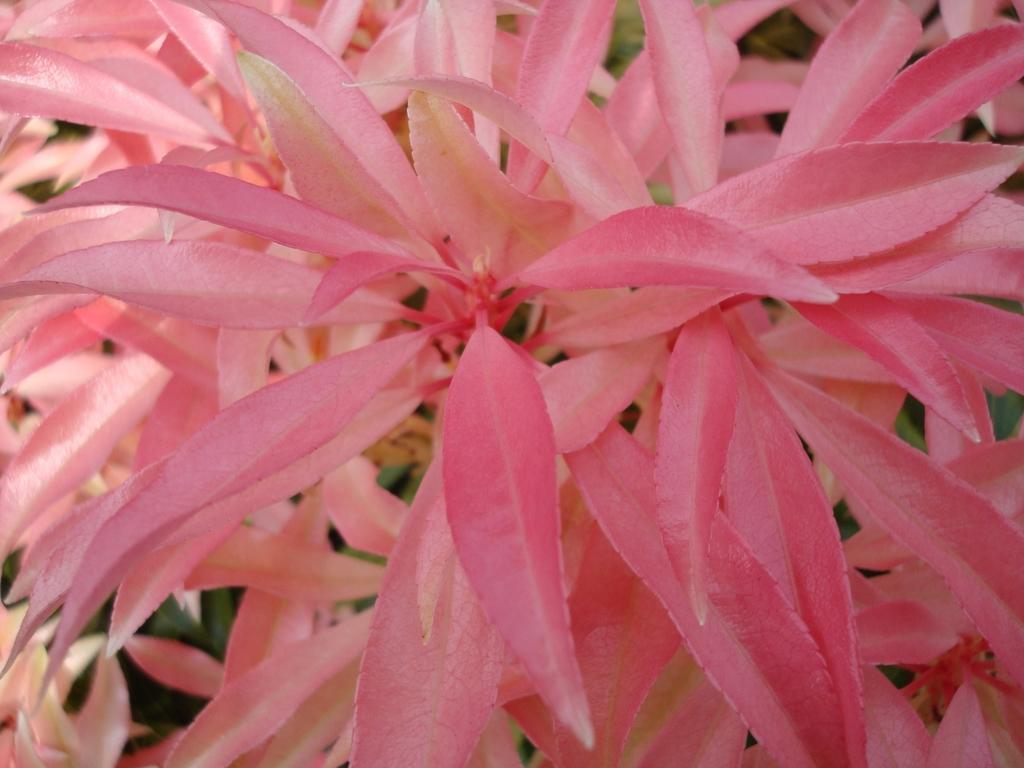What type of living organisms can be seen in the image? Plants can be seen in the image. What type of wound can be seen on the plants in the image? There is no wound visible on the plants in the image, as the provided fact only mentions the presence of plants. 